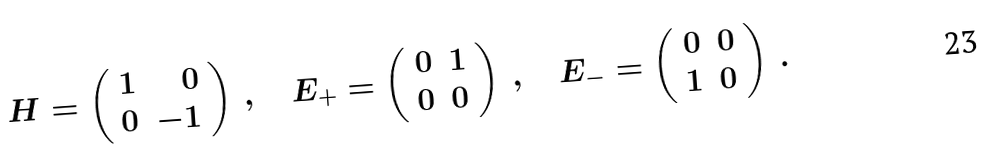Convert formula to latex. <formula><loc_0><loc_0><loc_500><loc_500>H = \left ( \begin{array} { c r } 1 & 0 \\ 0 & - 1 \end{array} \right ) \, , \quad E _ { + } = \left ( \begin{array} { c c } 0 & 1 \\ 0 & 0 \end{array} \right ) \, , \quad E _ { - } = \left ( \begin{array} { c c } 0 & 0 \\ 1 & 0 \end{array} \right ) \, .</formula> 